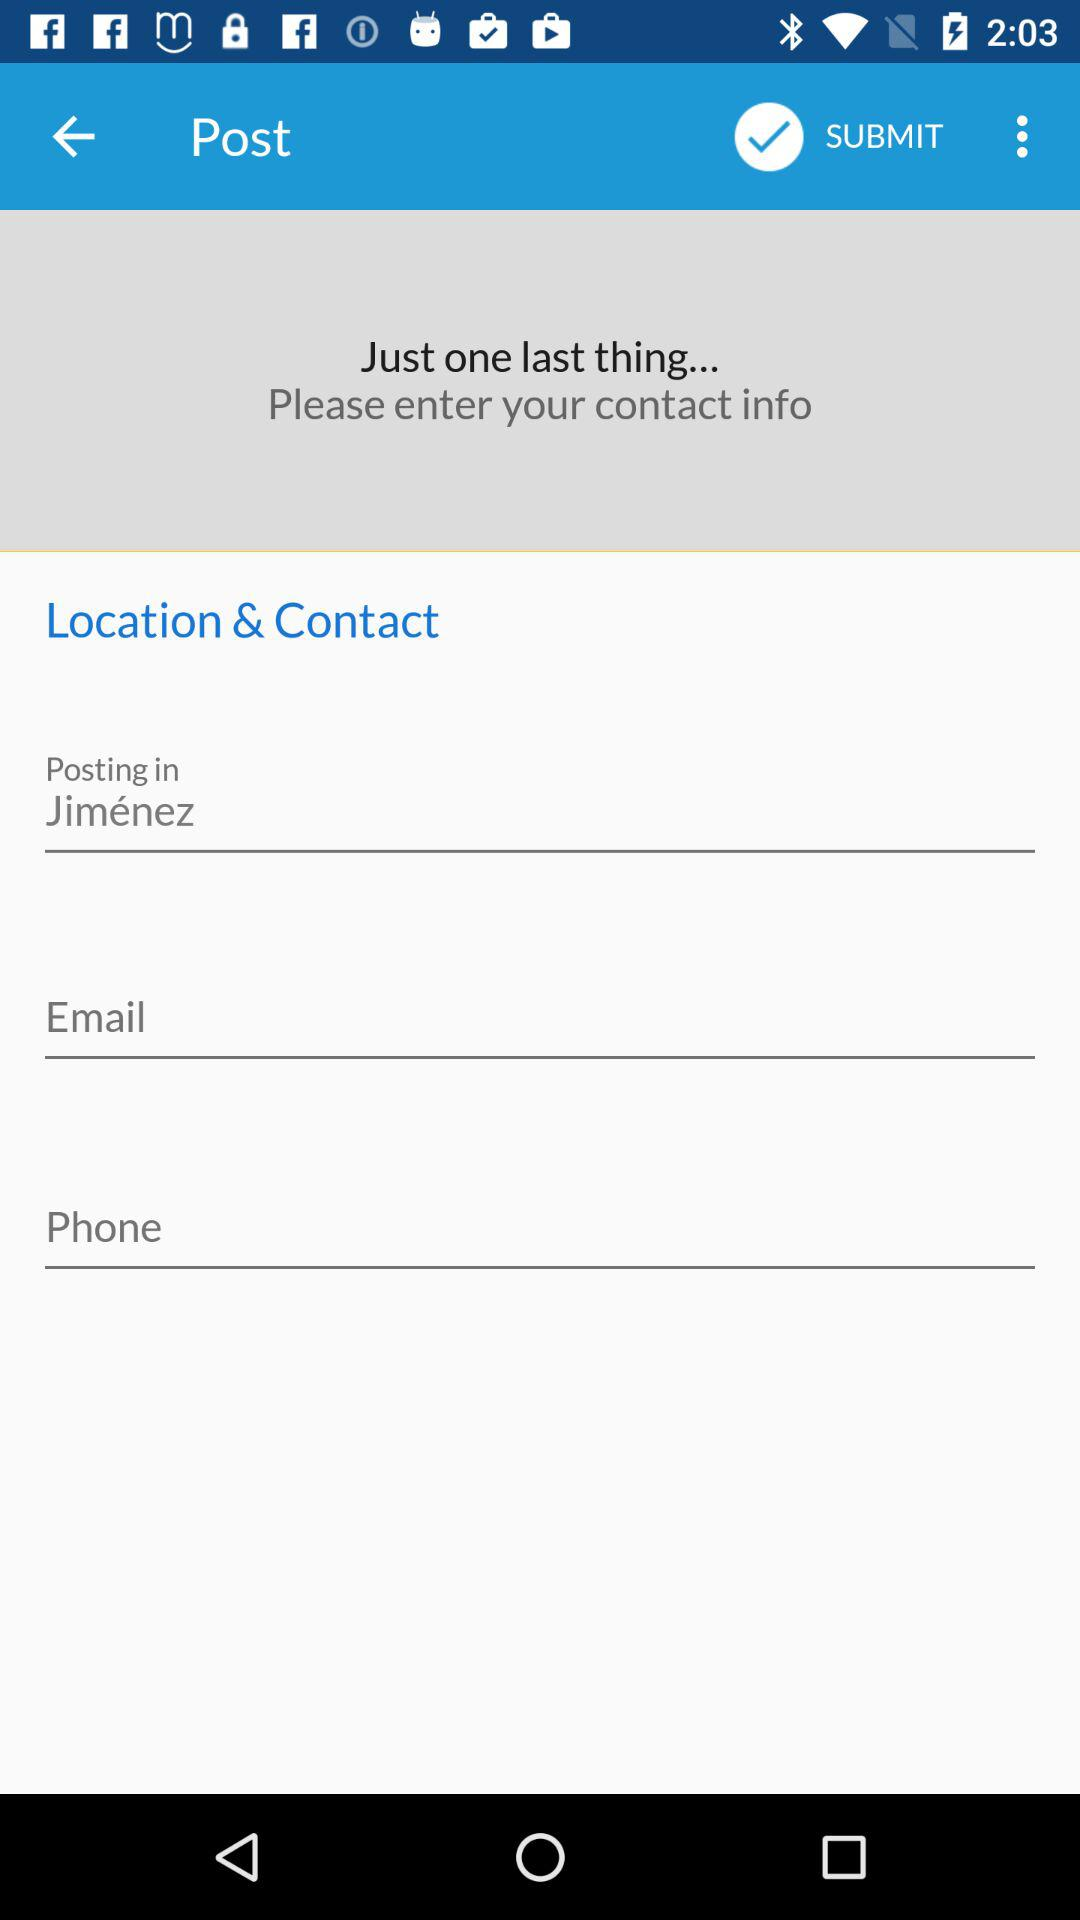How many text inputs are there for user contact info?
Answer the question using a single word or phrase. 3 